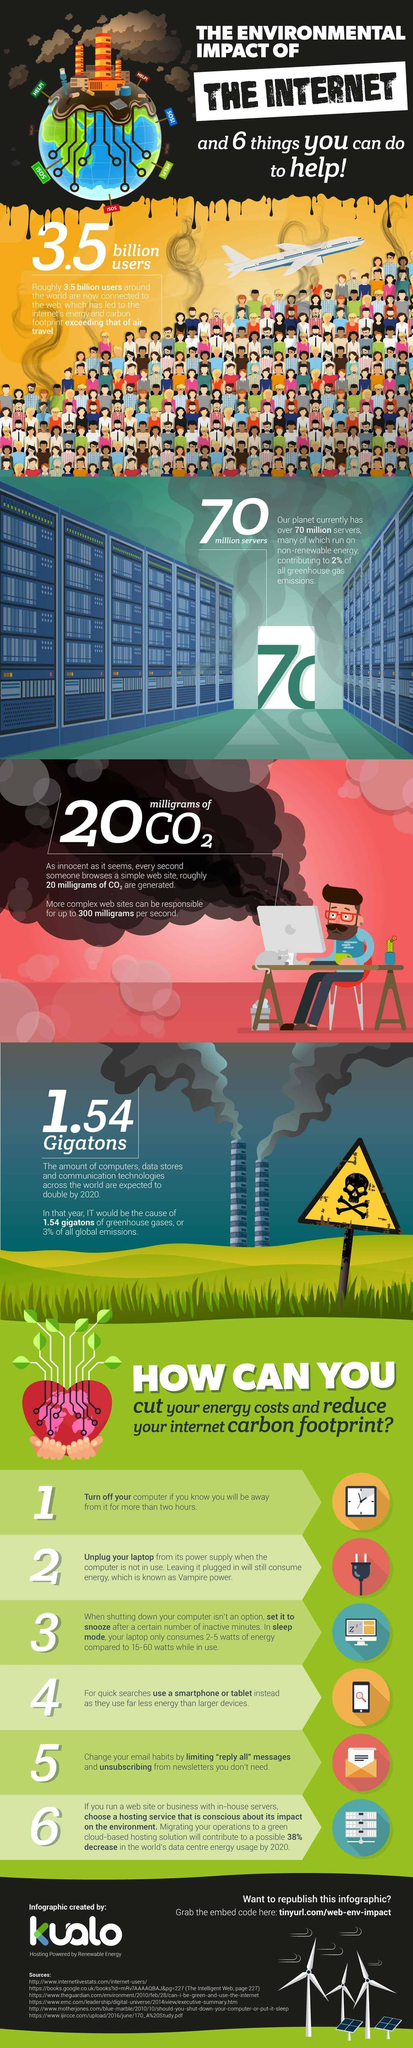How many sources are listed at the bottom?
Answer the question with a short phrase. 6 